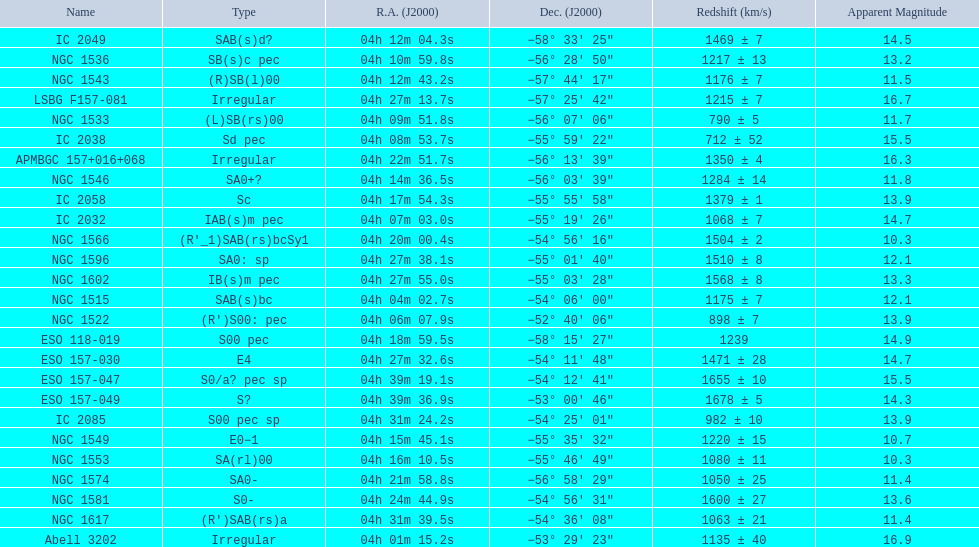Specify the member with the highest visible magnitude. Abell 3202. 